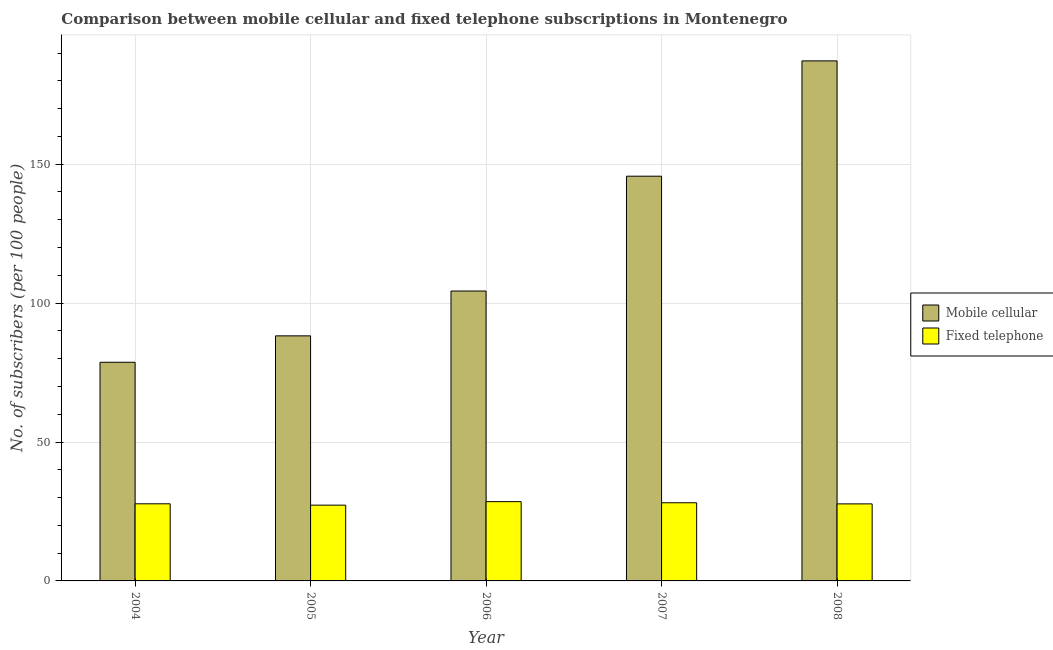How many groups of bars are there?
Your response must be concise. 5. Are the number of bars per tick equal to the number of legend labels?
Your answer should be very brief. Yes. Are the number of bars on each tick of the X-axis equal?
Make the answer very short. Yes. How many bars are there on the 3rd tick from the left?
Ensure brevity in your answer.  2. How many bars are there on the 3rd tick from the right?
Offer a very short reply. 2. What is the number of fixed telephone subscribers in 2007?
Offer a terse response. 28.13. Across all years, what is the maximum number of mobile cellular subscribers?
Your response must be concise. 187.19. Across all years, what is the minimum number of fixed telephone subscribers?
Give a very brief answer. 27.27. In which year was the number of mobile cellular subscribers maximum?
Keep it short and to the point. 2008. In which year was the number of fixed telephone subscribers minimum?
Offer a very short reply. 2005. What is the total number of mobile cellular subscribers in the graph?
Offer a terse response. 604.13. What is the difference between the number of mobile cellular subscribers in 2006 and that in 2007?
Your answer should be compact. -41.33. What is the difference between the number of fixed telephone subscribers in 2005 and the number of mobile cellular subscribers in 2004?
Provide a short and direct response. -0.48. What is the average number of fixed telephone subscribers per year?
Your answer should be very brief. 27.89. In the year 2004, what is the difference between the number of fixed telephone subscribers and number of mobile cellular subscribers?
Offer a very short reply. 0. What is the ratio of the number of mobile cellular subscribers in 2004 to that in 2008?
Provide a succinct answer. 0.42. Is the number of mobile cellular subscribers in 2005 less than that in 2006?
Your answer should be compact. Yes. Is the difference between the number of mobile cellular subscribers in 2005 and 2007 greater than the difference between the number of fixed telephone subscribers in 2005 and 2007?
Offer a terse response. No. What is the difference between the highest and the second highest number of fixed telephone subscribers?
Make the answer very short. 0.4. What is the difference between the highest and the lowest number of fixed telephone subscribers?
Your answer should be compact. 1.26. What does the 1st bar from the left in 2006 represents?
Offer a very short reply. Mobile cellular. What does the 1st bar from the right in 2005 represents?
Provide a short and direct response. Fixed telephone. How many years are there in the graph?
Keep it short and to the point. 5. Are the values on the major ticks of Y-axis written in scientific E-notation?
Keep it short and to the point. No. How many legend labels are there?
Offer a terse response. 2. How are the legend labels stacked?
Offer a very short reply. Vertical. What is the title of the graph?
Offer a terse response. Comparison between mobile cellular and fixed telephone subscriptions in Montenegro. Does "Total Population" appear as one of the legend labels in the graph?
Keep it short and to the point. No. What is the label or title of the Y-axis?
Offer a terse response. No. of subscribers (per 100 people). What is the No. of subscribers (per 100 people) in Mobile cellular in 2004?
Your answer should be compact. 78.7. What is the No. of subscribers (per 100 people) of Fixed telephone in 2004?
Ensure brevity in your answer.  27.76. What is the No. of subscribers (per 100 people) of Mobile cellular in 2005?
Provide a short and direct response. 88.21. What is the No. of subscribers (per 100 people) of Fixed telephone in 2005?
Provide a succinct answer. 27.27. What is the No. of subscribers (per 100 people) in Mobile cellular in 2006?
Your response must be concise. 104.35. What is the No. of subscribers (per 100 people) in Fixed telephone in 2006?
Offer a terse response. 28.53. What is the No. of subscribers (per 100 people) of Mobile cellular in 2007?
Your answer should be very brief. 145.68. What is the No. of subscribers (per 100 people) in Fixed telephone in 2007?
Provide a short and direct response. 28.13. What is the No. of subscribers (per 100 people) in Mobile cellular in 2008?
Offer a terse response. 187.19. What is the No. of subscribers (per 100 people) of Fixed telephone in 2008?
Offer a very short reply. 27.73. Across all years, what is the maximum No. of subscribers (per 100 people) in Mobile cellular?
Provide a short and direct response. 187.19. Across all years, what is the maximum No. of subscribers (per 100 people) in Fixed telephone?
Provide a succinct answer. 28.53. Across all years, what is the minimum No. of subscribers (per 100 people) in Mobile cellular?
Provide a succinct answer. 78.7. Across all years, what is the minimum No. of subscribers (per 100 people) of Fixed telephone?
Ensure brevity in your answer.  27.27. What is the total No. of subscribers (per 100 people) of Mobile cellular in the graph?
Provide a succinct answer. 604.13. What is the total No. of subscribers (per 100 people) of Fixed telephone in the graph?
Keep it short and to the point. 139.43. What is the difference between the No. of subscribers (per 100 people) of Mobile cellular in 2004 and that in 2005?
Provide a short and direct response. -9.51. What is the difference between the No. of subscribers (per 100 people) in Fixed telephone in 2004 and that in 2005?
Your answer should be very brief. 0.48. What is the difference between the No. of subscribers (per 100 people) of Mobile cellular in 2004 and that in 2006?
Your answer should be compact. -25.65. What is the difference between the No. of subscribers (per 100 people) of Fixed telephone in 2004 and that in 2006?
Your answer should be very brief. -0.78. What is the difference between the No. of subscribers (per 100 people) of Mobile cellular in 2004 and that in 2007?
Provide a short and direct response. -66.97. What is the difference between the No. of subscribers (per 100 people) of Fixed telephone in 2004 and that in 2007?
Give a very brief answer. -0.38. What is the difference between the No. of subscribers (per 100 people) of Mobile cellular in 2004 and that in 2008?
Ensure brevity in your answer.  -108.48. What is the difference between the No. of subscribers (per 100 people) in Fixed telephone in 2004 and that in 2008?
Offer a very short reply. 0.03. What is the difference between the No. of subscribers (per 100 people) in Mobile cellular in 2005 and that in 2006?
Offer a terse response. -16.14. What is the difference between the No. of subscribers (per 100 people) of Fixed telephone in 2005 and that in 2006?
Offer a terse response. -1.26. What is the difference between the No. of subscribers (per 100 people) of Mobile cellular in 2005 and that in 2007?
Keep it short and to the point. -57.47. What is the difference between the No. of subscribers (per 100 people) of Fixed telephone in 2005 and that in 2007?
Provide a short and direct response. -0.86. What is the difference between the No. of subscribers (per 100 people) in Mobile cellular in 2005 and that in 2008?
Provide a succinct answer. -98.98. What is the difference between the No. of subscribers (per 100 people) in Fixed telephone in 2005 and that in 2008?
Provide a succinct answer. -0.46. What is the difference between the No. of subscribers (per 100 people) in Mobile cellular in 2006 and that in 2007?
Your answer should be very brief. -41.33. What is the difference between the No. of subscribers (per 100 people) of Fixed telephone in 2006 and that in 2007?
Give a very brief answer. 0.4. What is the difference between the No. of subscribers (per 100 people) of Mobile cellular in 2006 and that in 2008?
Give a very brief answer. -82.84. What is the difference between the No. of subscribers (per 100 people) in Fixed telephone in 2006 and that in 2008?
Your answer should be very brief. 0.81. What is the difference between the No. of subscribers (per 100 people) of Mobile cellular in 2007 and that in 2008?
Offer a very short reply. -41.51. What is the difference between the No. of subscribers (per 100 people) of Fixed telephone in 2007 and that in 2008?
Give a very brief answer. 0.41. What is the difference between the No. of subscribers (per 100 people) in Mobile cellular in 2004 and the No. of subscribers (per 100 people) in Fixed telephone in 2005?
Keep it short and to the point. 51.43. What is the difference between the No. of subscribers (per 100 people) in Mobile cellular in 2004 and the No. of subscribers (per 100 people) in Fixed telephone in 2006?
Your response must be concise. 50.17. What is the difference between the No. of subscribers (per 100 people) in Mobile cellular in 2004 and the No. of subscribers (per 100 people) in Fixed telephone in 2007?
Your answer should be very brief. 50.57. What is the difference between the No. of subscribers (per 100 people) in Mobile cellular in 2004 and the No. of subscribers (per 100 people) in Fixed telephone in 2008?
Ensure brevity in your answer.  50.98. What is the difference between the No. of subscribers (per 100 people) of Mobile cellular in 2005 and the No. of subscribers (per 100 people) of Fixed telephone in 2006?
Your answer should be compact. 59.68. What is the difference between the No. of subscribers (per 100 people) of Mobile cellular in 2005 and the No. of subscribers (per 100 people) of Fixed telephone in 2007?
Your response must be concise. 60.08. What is the difference between the No. of subscribers (per 100 people) of Mobile cellular in 2005 and the No. of subscribers (per 100 people) of Fixed telephone in 2008?
Provide a succinct answer. 60.48. What is the difference between the No. of subscribers (per 100 people) of Mobile cellular in 2006 and the No. of subscribers (per 100 people) of Fixed telephone in 2007?
Your answer should be very brief. 76.22. What is the difference between the No. of subscribers (per 100 people) of Mobile cellular in 2006 and the No. of subscribers (per 100 people) of Fixed telephone in 2008?
Your answer should be compact. 76.62. What is the difference between the No. of subscribers (per 100 people) of Mobile cellular in 2007 and the No. of subscribers (per 100 people) of Fixed telephone in 2008?
Keep it short and to the point. 117.95. What is the average No. of subscribers (per 100 people) in Mobile cellular per year?
Your response must be concise. 120.83. What is the average No. of subscribers (per 100 people) in Fixed telephone per year?
Make the answer very short. 27.89. In the year 2004, what is the difference between the No. of subscribers (per 100 people) of Mobile cellular and No. of subscribers (per 100 people) of Fixed telephone?
Make the answer very short. 50.95. In the year 2005, what is the difference between the No. of subscribers (per 100 people) of Mobile cellular and No. of subscribers (per 100 people) of Fixed telephone?
Offer a very short reply. 60.94. In the year 2006, what is the difference between the No. of subscribers (per 100 people) in Mobile cellular and No. of subscribers (per 100 people) in Fixed telephone?
Your answer should be very brief. 75.81. In the year 2007, what is the difference between the No. of subscribers (per 100 people) of Mobile cellular and No. of subscribers (per 100 people) of Fixed telephone?
Your response must be concise. 117.55. In the year 2008, what is the difference between the No. of subscribers (per 100 people) of Mobile cellular and No. of subscribers (per 100 people) of Fixed telephone?
Make the answer very short. 159.46. What is the ratio of the No. of subscribers (per 100 people) in Mobile cellular in 2004 to that in 2005?
Provide a succinct answer. 0.89. What is the ratio of the No. of subscribers (per 100 people) in Fixed telephone in 2004 to that in 2005?
Provide a short and direct response. 1.02. What is the ratio of the No. of subscribers (per 100 people) in Mobile cellular in 2004 to that in 2006?
Keep it short and to the point. 0.75. What is the ratio of the No. of subscribers (per 100 people) of Fixed telephone in 2004 to that in 2006?
Give a very brief answer. 0.97. What is the ratio of the No. of subscribers (per 100 people) of Mobile cellular in 2004 to that in 2007?
Your response must be concise. 0.54. What is the ratio of the No. of subscribers (per 100 people) of Fixed telephone in 2004 to that in 2007?
Make the answer very short. 0.99. What is the ratio of the No. of subscribers (per 100 people) in Mobile cellular in 2004 to that in 2008?
Keep it short and to the point. 0.42. What is the ratio of the No. of subscribers (per 100 people) of Fixed telephone in 2004 to that in 2008?
Offer a very short reply. 1. What is the ratio of the No. of subscribers (per 100 people) of Mobile cellular in 2005 to that in 2006?
Your response must be concise. 0.85. What is the ratio of the No. of subscribers (per 100 people) of Fixed telephone in 2005 to that in 2006?
Offer a very short reply. 0.96. What is the ratio of the No. of subscribers (per 100 people) in Mobile cellular in 2005 to that in 2007?
Give a very brief answer. 0.61. What is the ratio of the No. of subscribers (per 100 people) in Fixed telephone in 2005 to that in 2007?
Offer a very short reply. 0.97. What is the ratio of the No. of subscribers (per 100 people) of Mobile cellular in 2005 to that in 2008?
Ensure brevity in your answer.  0.47. What is the ratio of the No. of subscribers (per 100 people) in Fixed telephone in 2005 to that in 2008?
Your answer should be compact. 0.98. What is the ratio of the No. of subscribers (per 100 people) in Mobile cellular in 2006 to that in 2007?
Ensure brevity in your answer.  0.72. What is the ratio of the No. of subscribers (per 100 people) of Fixed telephone in 2006 to that in 2007?
Ensure brevity in your answer.  1.01. What is the ratio of the No. of subscribers (per 100 people) of Mobile cellular in 2006 to that in 2008?
Your answer should be very brief. 0.56. What is the ratio of the No. of subscribers (per 100 people) of Fixed telephone in 2006 to that in 2008?
Make the answer very short. 1.03. What is the ratio of the No. of subscribers (per 100 people) of Mobile cellular in 2007 to that in 2008?
Your response must be concise. 0.78. What is the ratio of the No. of subscribers (per 100 people) in Fixed telephone in 2007 to that in 2008?
Offer a terse response. 1.01. What is the difference between the highest and the second highest No. of subscribers (per 100 people) in Mobile cellular?
Offer a terse response. 41.51. What is the difference between the highest and the second highest No. of subscribers (per 100 people) of Fixed telephone?
Your answer should be very brief. 0.4. What is the difference between the highest and the lowest No. of subscribers (per 100 people) in Mobile cellular?
Make the answer very short. 108.48. What is the difference between the highest and the lowest No. of subscribers (per 100 people) in Fixed telephone?
Your response must be concise. 1.26. 